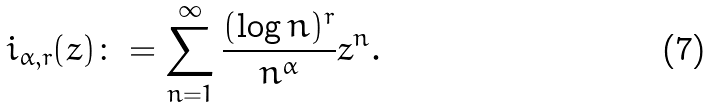<formula> <loc_0><loc_0><loc_500><loc_500>\L i _ { \alpha , r } ( z ) \colon = \sum _ { n = 1 } ^ { \infty } \frac { ( \log { n } ) ^ { r } } { n ^ { \alpha } } z ^ { n } .</formula> 